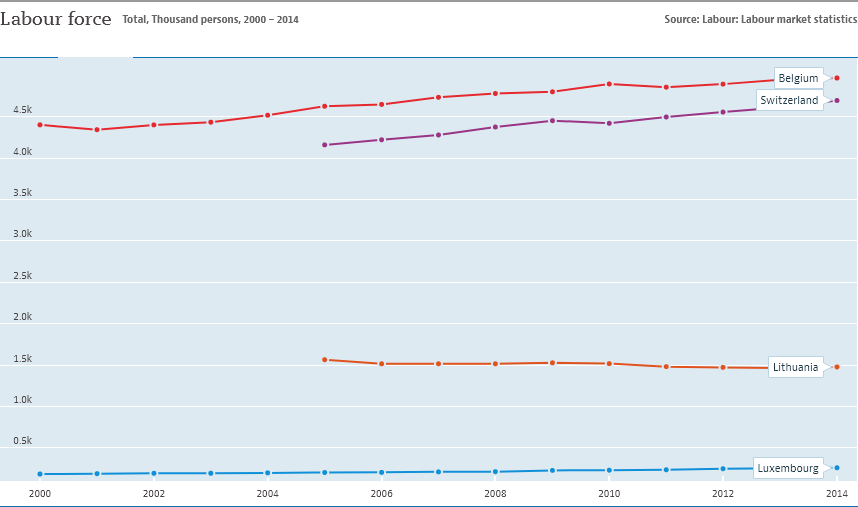Give some essential details in this illustration. The graph shows the labor force of two countries, Switzerland and Belgium, and both countries have a labor force of more than 4,000 people. Lithuania and Luxembourg did not have a higher value than Belgium in 2006. 